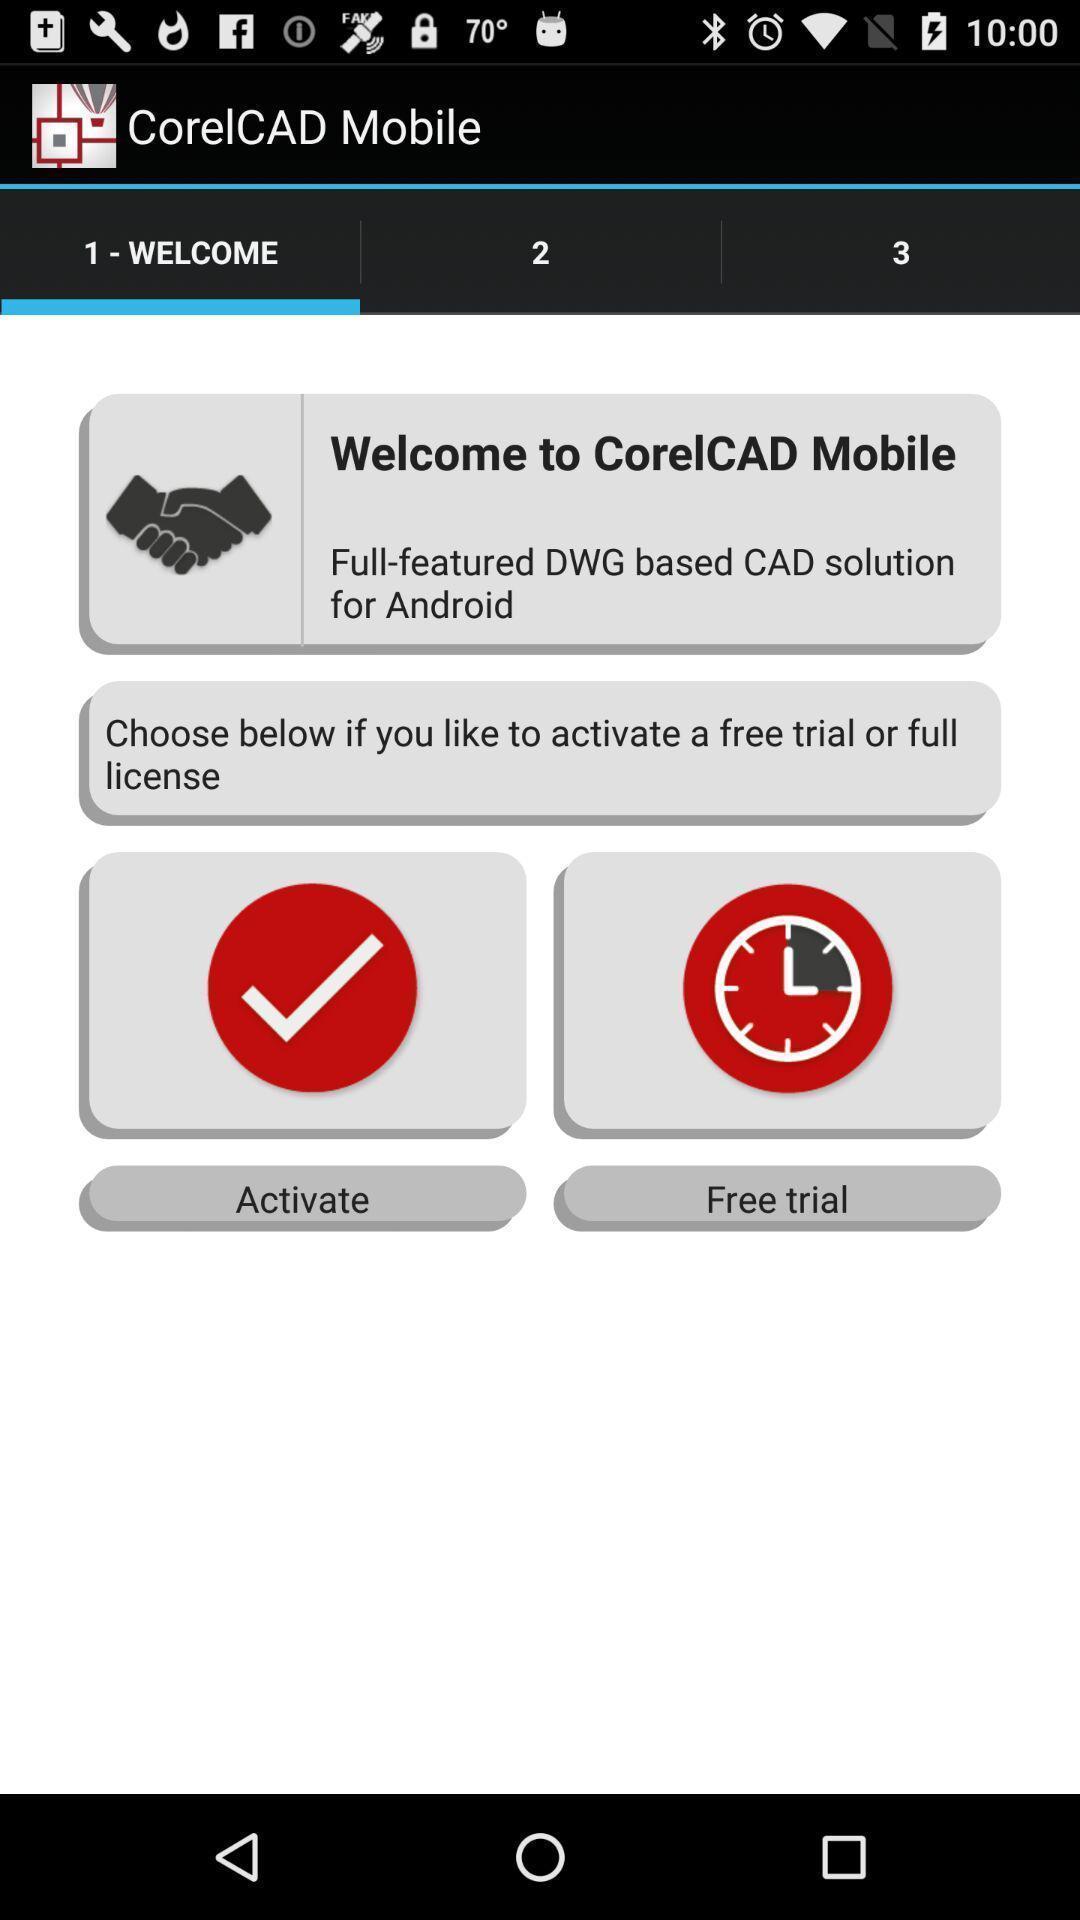Summarize the main components in this picture. Welcome page of cad app. 